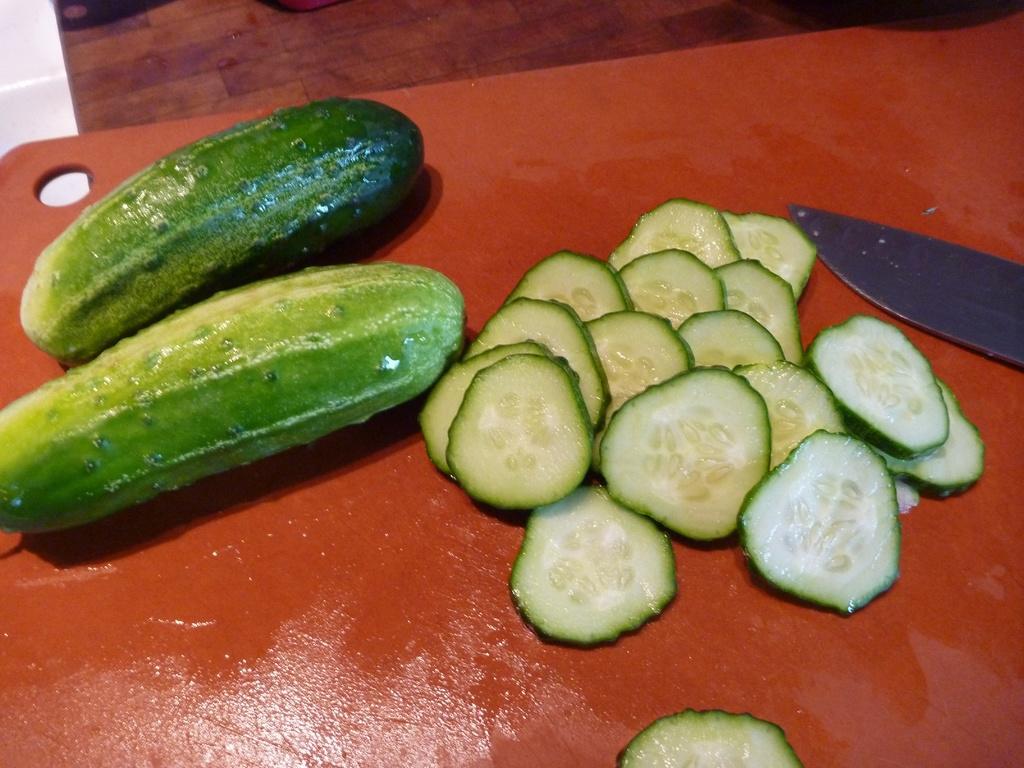Could you give a brief overview of what you see in this image? In this image there are sliced pieces, vegetables and a knife on the plate. 